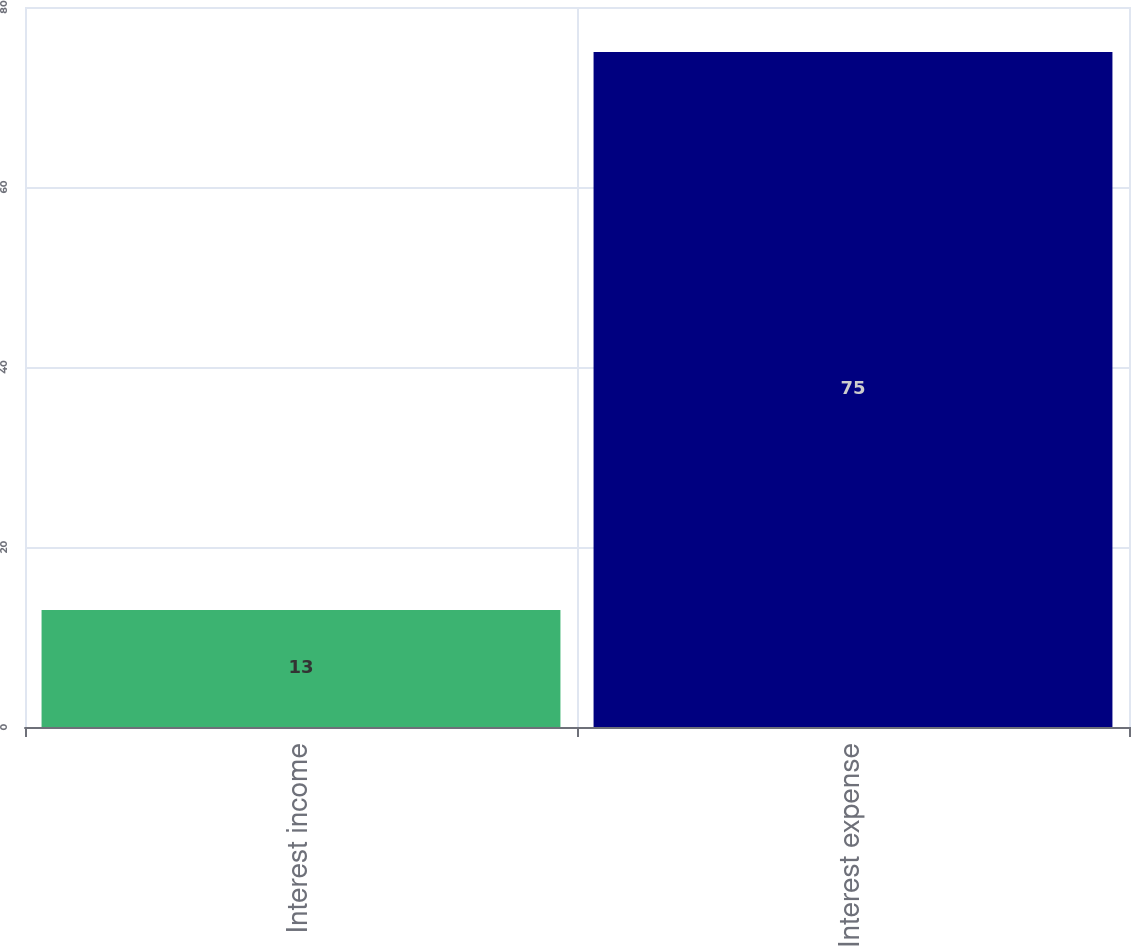<chart> <loc_0><loc_0><loc_500><loc_500><bar_chart><fcel>Interest income<fcel>Interest expense<nl><fcel>13<fcel>75<nl></chart> 